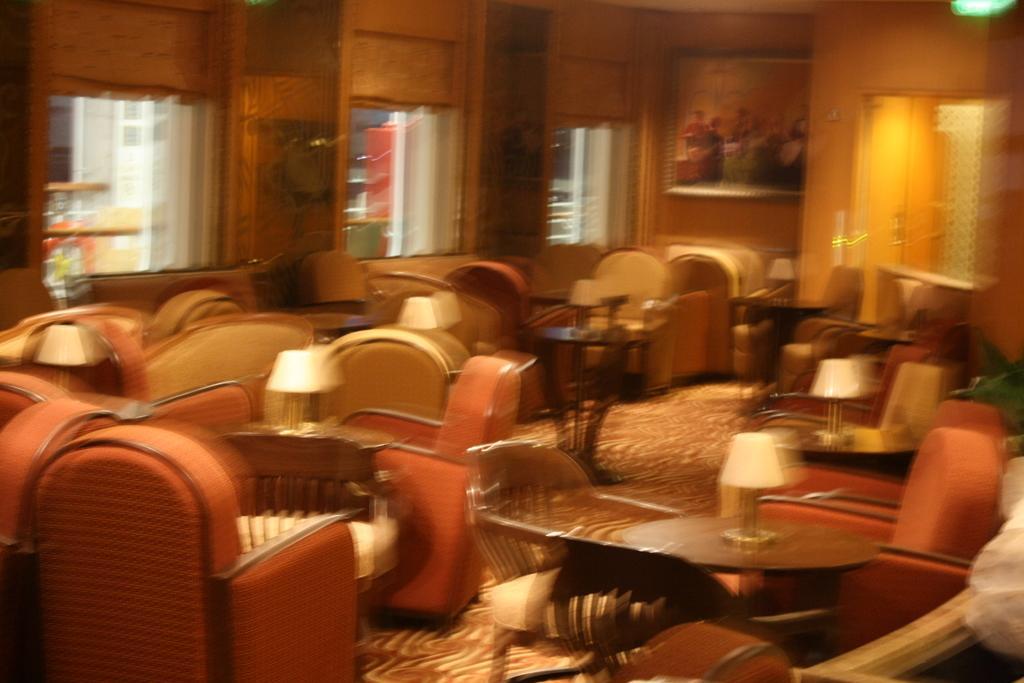Please provide a concise description of this image. In this image, we can see some chairs and tables. There are windows in the middle of the image. There is a painting in the top right of the image. 